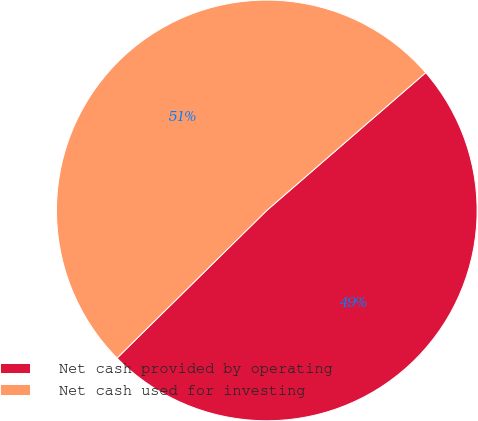Convert chart to OTSL. <chart><loc_0><loc_0><loc_500><loc_500><pie_chart><fcel>Net cash provided by operating<fcel>Net cash used for investing<nl><fcel>48.98%<fcel>51.02%<nl></chart> 